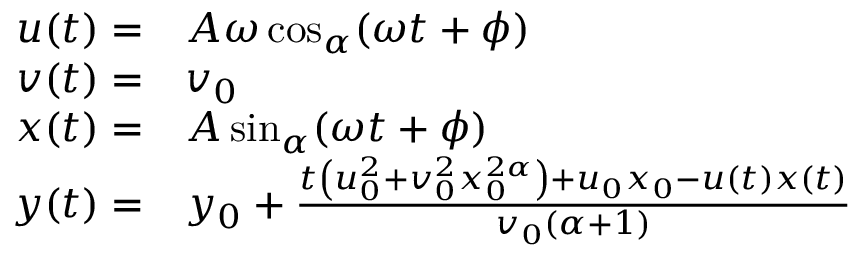<formula> <loc_0><loc_0><loc_500><loc_500>\begin{array} { r l } { u ( t ) = } & { A \omega \cos _ { \alpha } ( \omega t + \phi ) } \\ { v ( t ) = } & { v _ { 0 } } \\ { x ( t ) = } & { A \sin _ { \alpha } ( \omega t + \phi ) } \\ { y ( t ) = } & { y _ { 0 } + \frac { t \left ( u _ { 0 } ^ { 2 } + v _ { 0 } ^ { 2 } x _ { 0 } ^ { 2 \alpha } \right ) + u _ { 0 } x _ { 0 } - u ( t ) x ( t ) } { v _ { 0 } ( \alpha + 1 ) } } \end{array}</formula> 